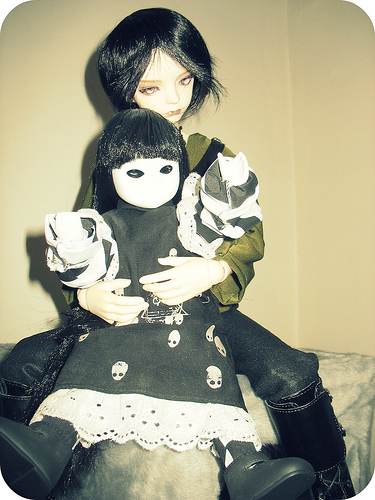<image>
Is there a small doll next to the large doll? No. The small doll is not positioned next to the large doll. They are located in different areas of the scene. Is the small doll in front of the girl doll? Yes. The small doll is positioned in front of the girl doll, appearing closer to the camera viewpoint. 